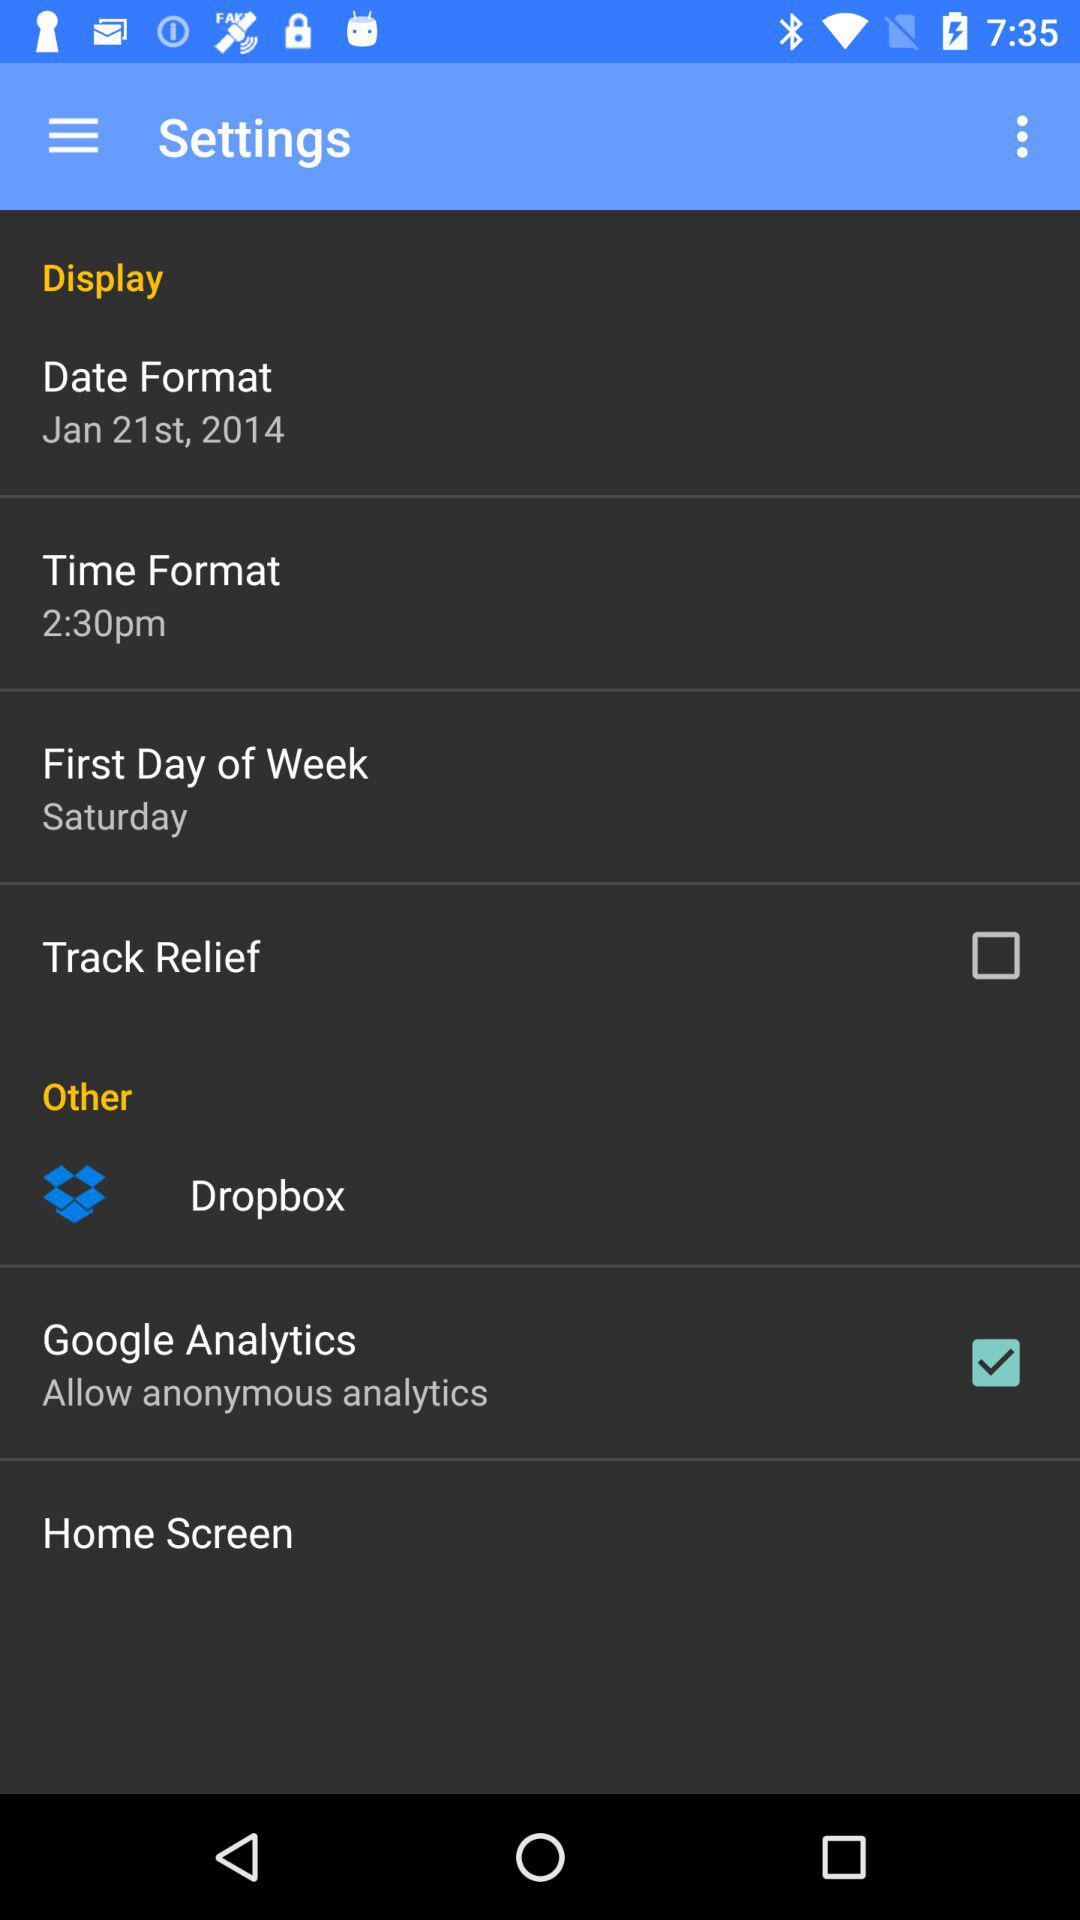What's the status of Google Analytics? The status is on. 